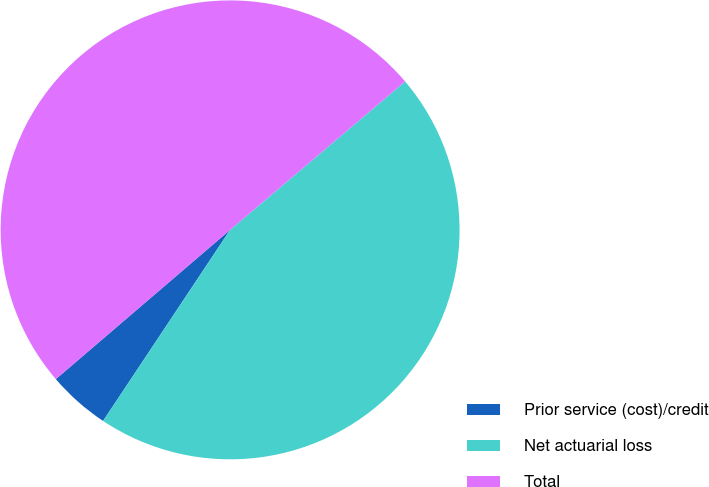Convert chart. <chart><loc_0><loc_0><loc_500><loc_500><pie_chart><fcel>Prior service (cost)/credit<fcel>Net actuarial loss<fcel>Total<nl><fcel>4.39%<fcel>45.53%<fcel>50.08%<nl></chart> 